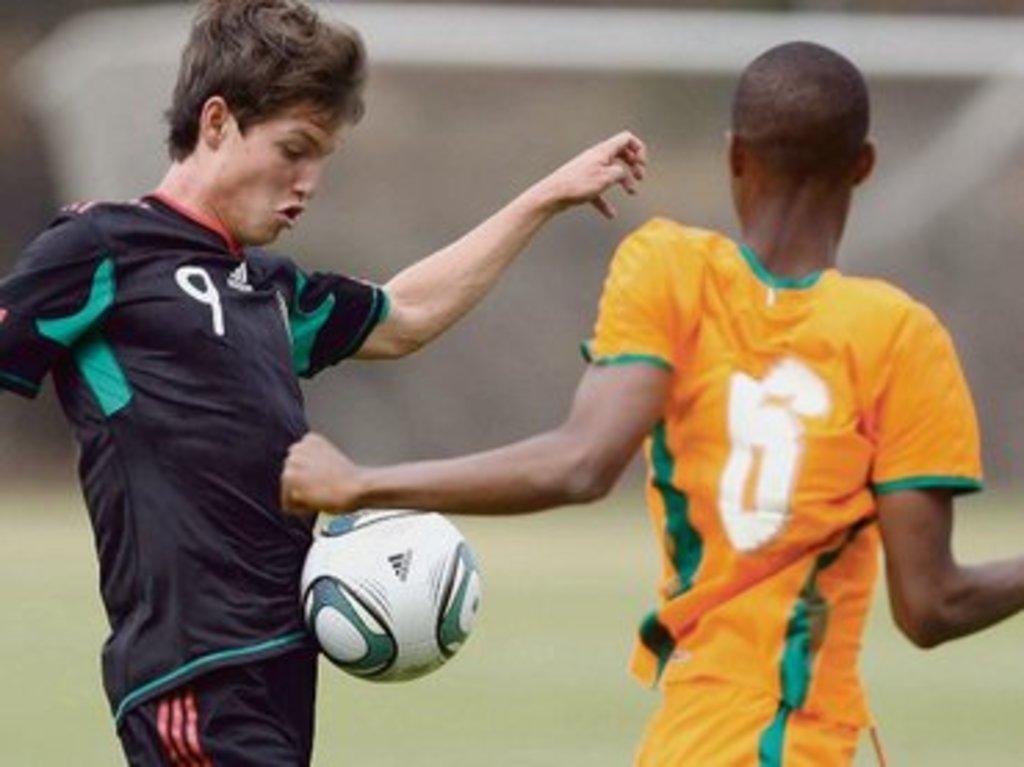How would you summarize this image in a sentence or two? This image is taken in outdoors. There are two boys in this image. They are playing football. In the middle of the image there is a ball. In the bottom of the image there is a ground with grass on it. 